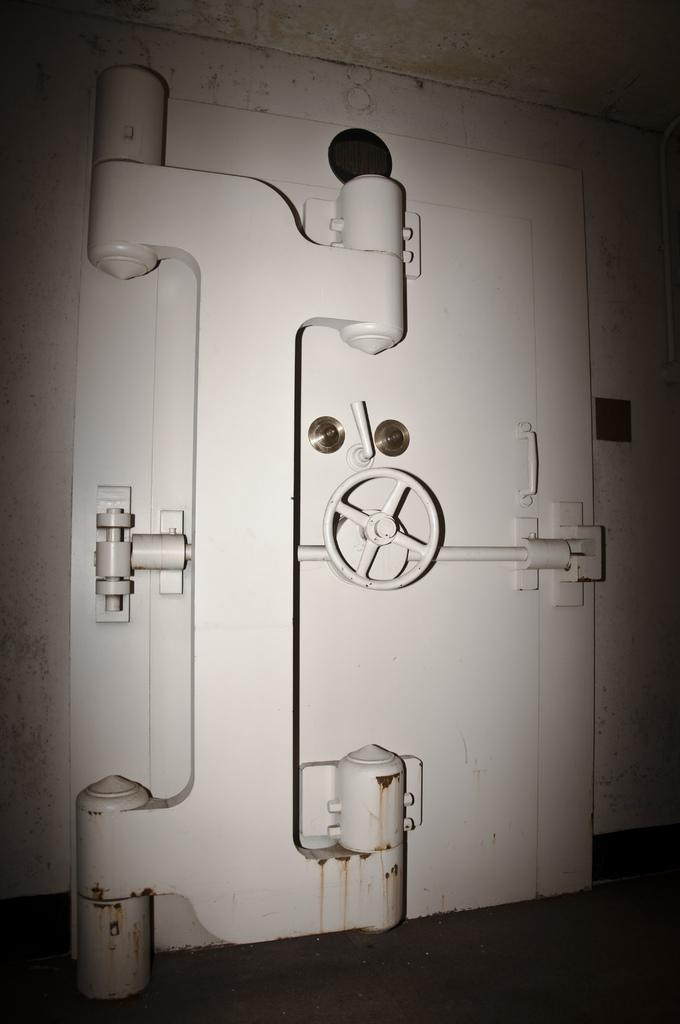What is the main object in the image? There is an iron locker door in the image. What is behind the locker door? The facts provided do not give information about what is behind the locker door. What can be seen next to the locker door? There is a wall in the image. What part of the locker door can be used to open or close it? There is a handle in the image. What surface is the locker door and wall standing on? There is a floor in the image. What type of decision can be seen on the locker door in the image? There is no decision visible on the locker door in the image. 